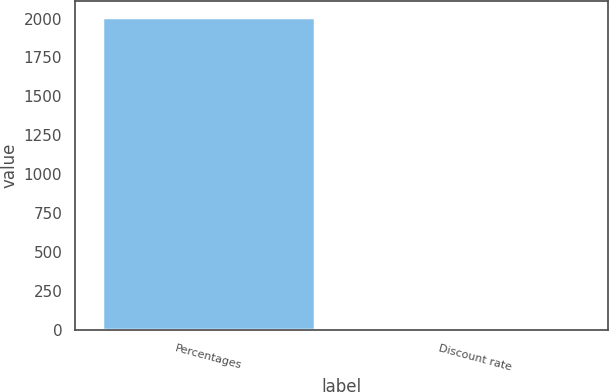Convert chart. <chart><loc_0><loc_0><loc_500><loc_500><bar_chart><fcel>Percentages<fcel>Discount rate<nl><fcel>2012<fcel>5.05<nl></chart> 